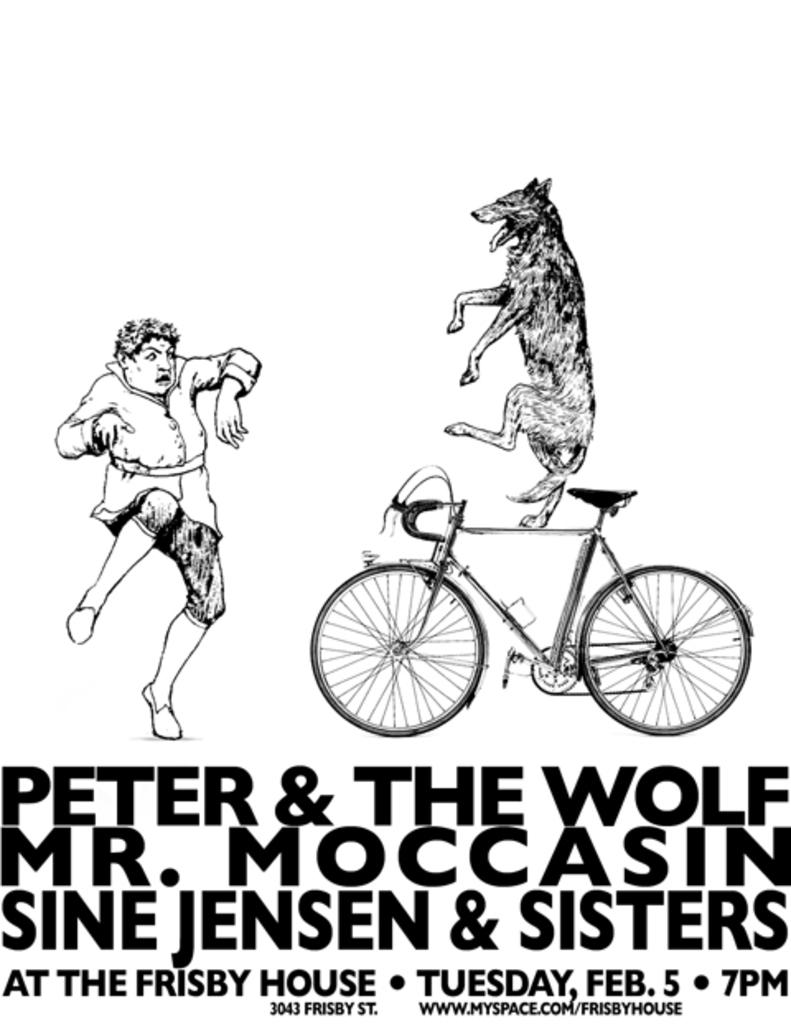What subjects are depicted in the sketch in the image? There is a sketch of a person and a dog in the image. What is the dog doing in the sketch? The dog is on a bicycle in the sketch. Is there any text or writing on the image? Yes, there is writing on the image. How many legs does the lawyer have in the image? There is no lawyer present in the image, so it is not possible to determine the number of legs they might have. 